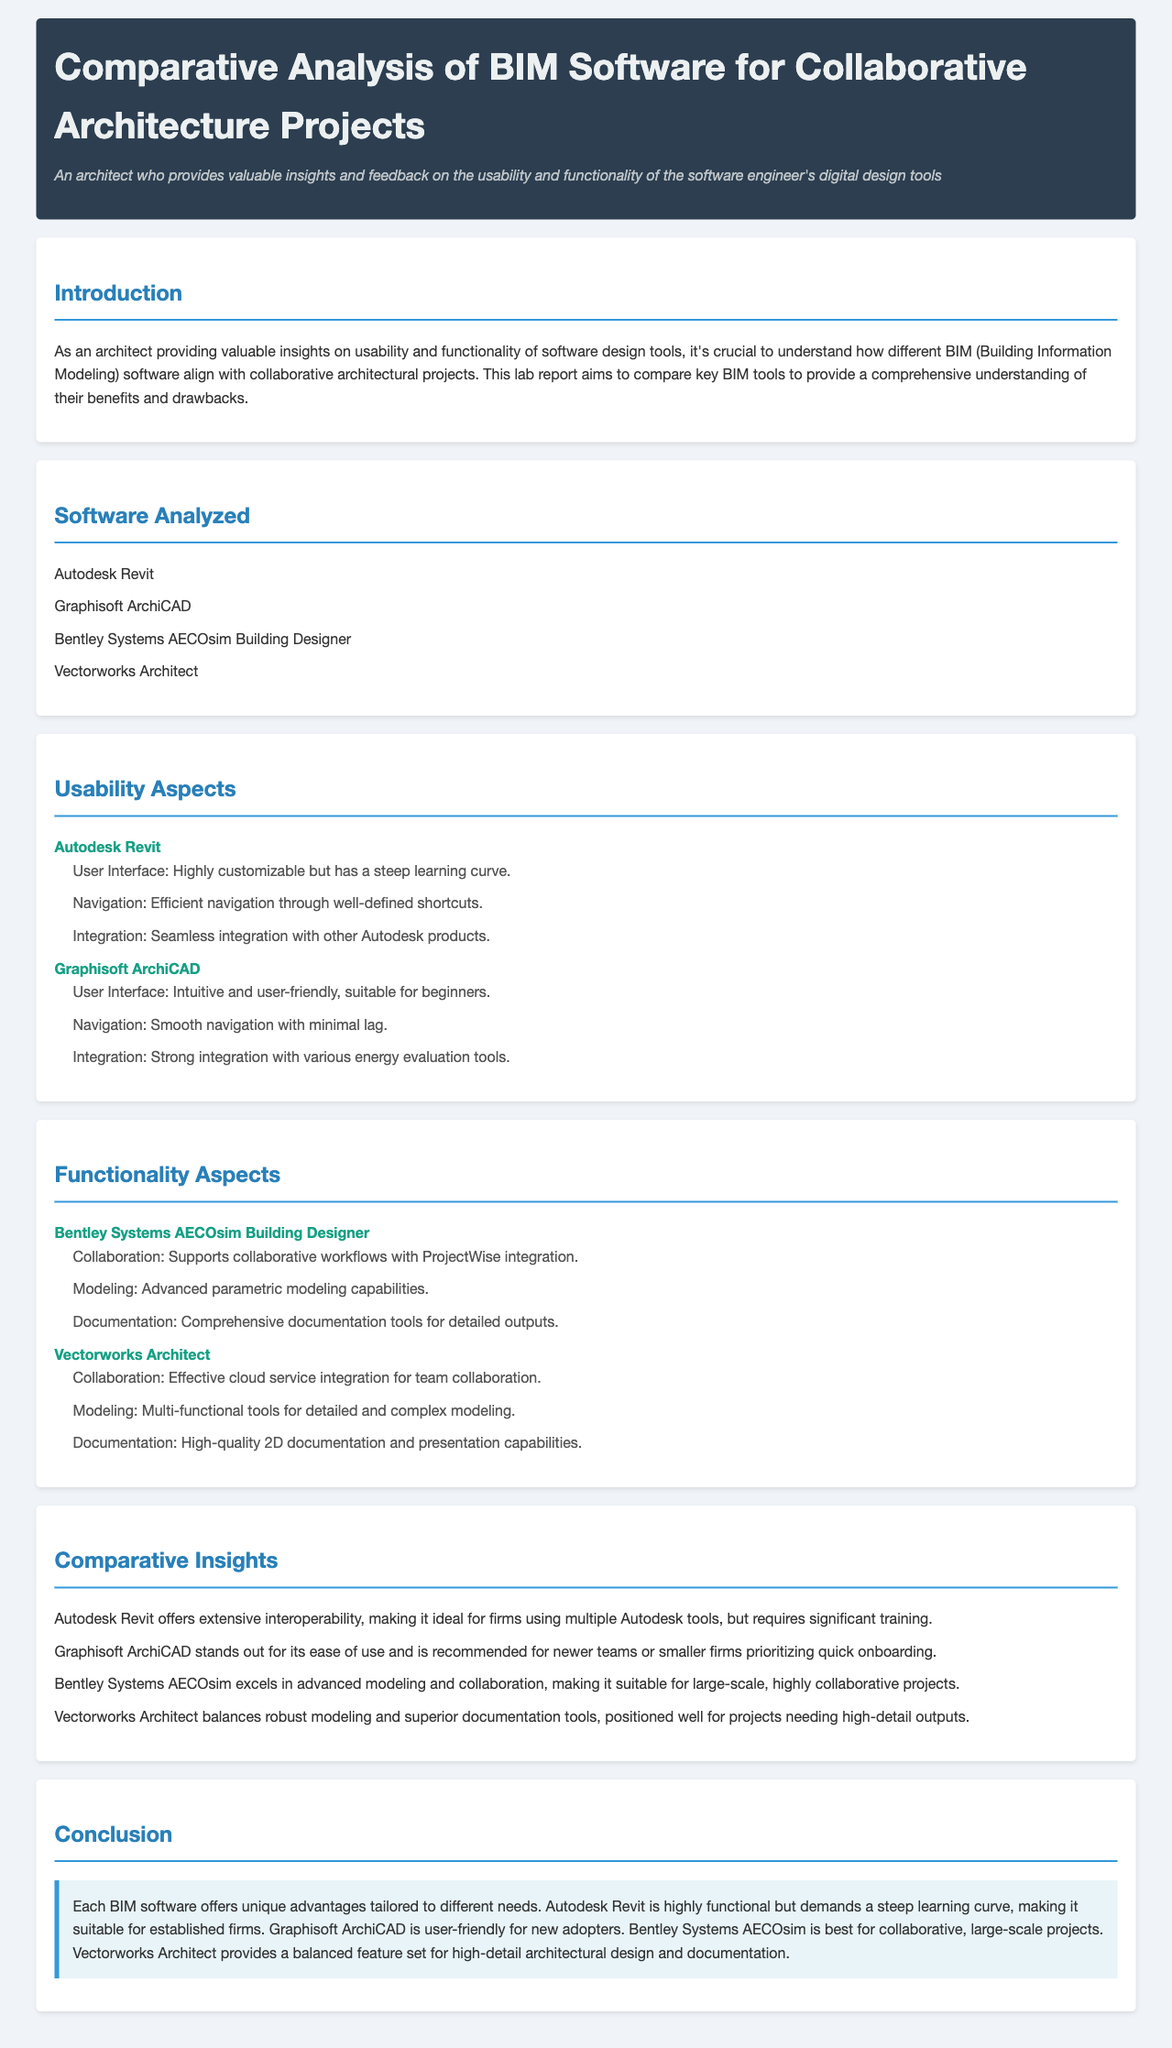What is the title of the lab report? The title is provided in the header section of the document.
Answer: Comparative Analysis of BIM Software for Collaborative Architecture Projects Which software is described as user-friendly and suitable for beginners? The document describes Graphisoft ArchiCAD in this context under the usability aspects.
Answer: Graphisoft ArchiCAD What integration feature does Autodesk Revit offer? The document mentions seamless integration with other Autodesk products under usability aspects.
Answer: Seamless integration Which BIM software excels in advanced modeling and collaboration? The document identifies Bentley Systems AECOsim Building Designer as excelling in these areas in the functionality aspects.
Answer: Bentley Systems AECOsim Building Designer How does Vectorworks Architect approach team collaboration? The document states that Vectorworks Architect has effective cloud service integration for team collaboration.
Answer: Effective cloud service integration What is the conclusion about Autodesk Revit regarding its learning curve? The conclusion section provides an insight into Autodesk Revit's learning curve as steep.
Answer: Steep learning curve What characteristic is highlighted for Graphisoft ArchiCAD in the comparative insights? The comparative insights highlight ease of use as a key characteristic for Graphisoft ArchiCAD.
Answer: Ease of use How many BIM software applications were analyzed in the report? The document lists four software applications analyzed, which can be obtained from the software analyzed section.
Answer: Four 